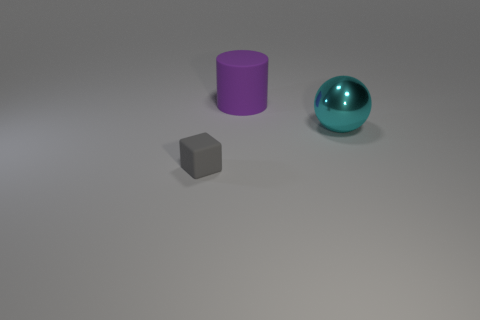Are there any other things that are made of the same material as the cyan thing?
Provide a succinct answer. No. What color is the matte thing behind the big object that is on the right side of the big object behind the big shiny ball?
Your answer should be very brief. Purple. How many large things are either blue cylinders or things?
Your answer should be compact. 2. Are there the same number of small gray rubber objects that are on the left side of the gray matte thing and big cyan metal spheres?
Provide a succinct answer. No. Are there any large purple cylinders behind the gray cube?
Provide a succinct answer. Yes. How many shiny things are either big spheres or purple objects?
Provide a short and direct response. 1. What number of big balls are on the right side of the gray matte cube?
Provide a succinct answer. 1. Is there a sphere of the same size as the purple thing?
Provide a short and direct response. Yes. Are there any other blocks that have the same color as the block?
Provide a short and direct response. No. Is there anything else that is the same size as the purple matte thing?
Give a very brief answer. Yes. 